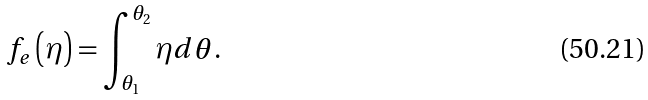Convert formula to latex. <formula><loc_0><loc_0><loc_500><loc_500>f _ { e } \left ( \eta \right ) = \int _ { \theta _ { 1 } } ^ { \theta _ { 2 } } \eta d \theta .</formula> 